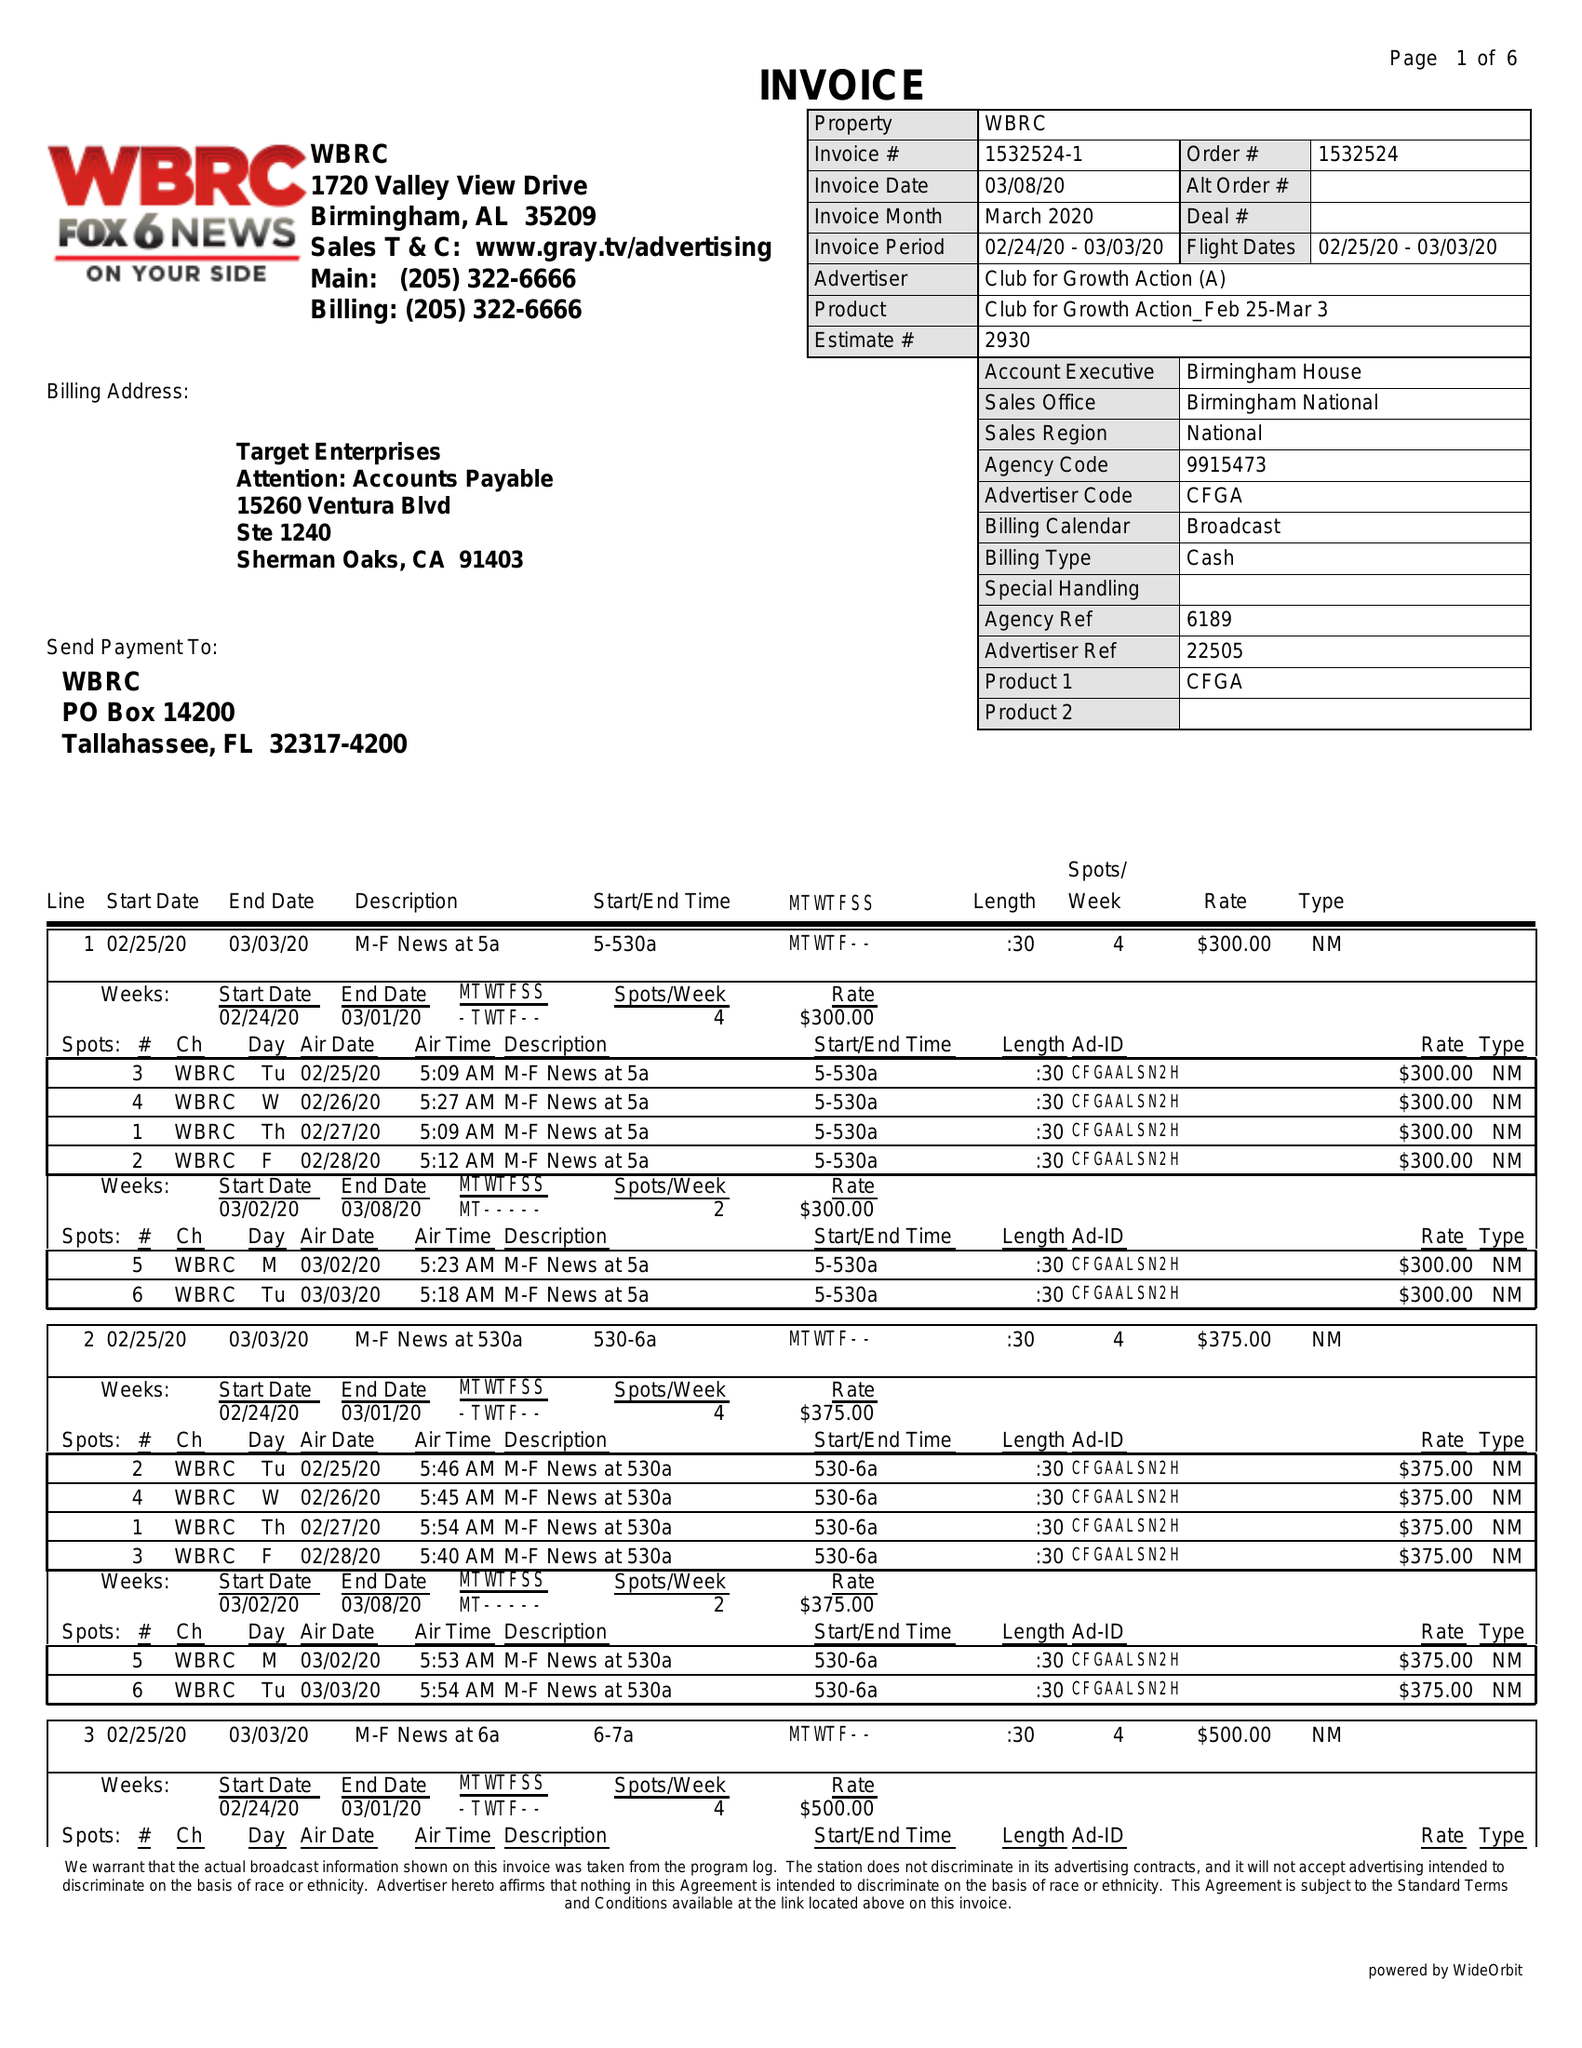What is the value for the contract_num?
Answer the question using a single word or phrase. 1532524 